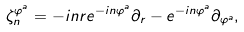<formula> <loc_0><loc_0><loc_500><loc_500>\zeta _ { n } ^ { \varphi ^ { a } } = - i n r e ^ { - i n \varphi ^ { a } } \partial _ { r } - e ^ { - i n \varphi ^ { a } } \partial _ { \varphi ^ { a } } ,</formula> 